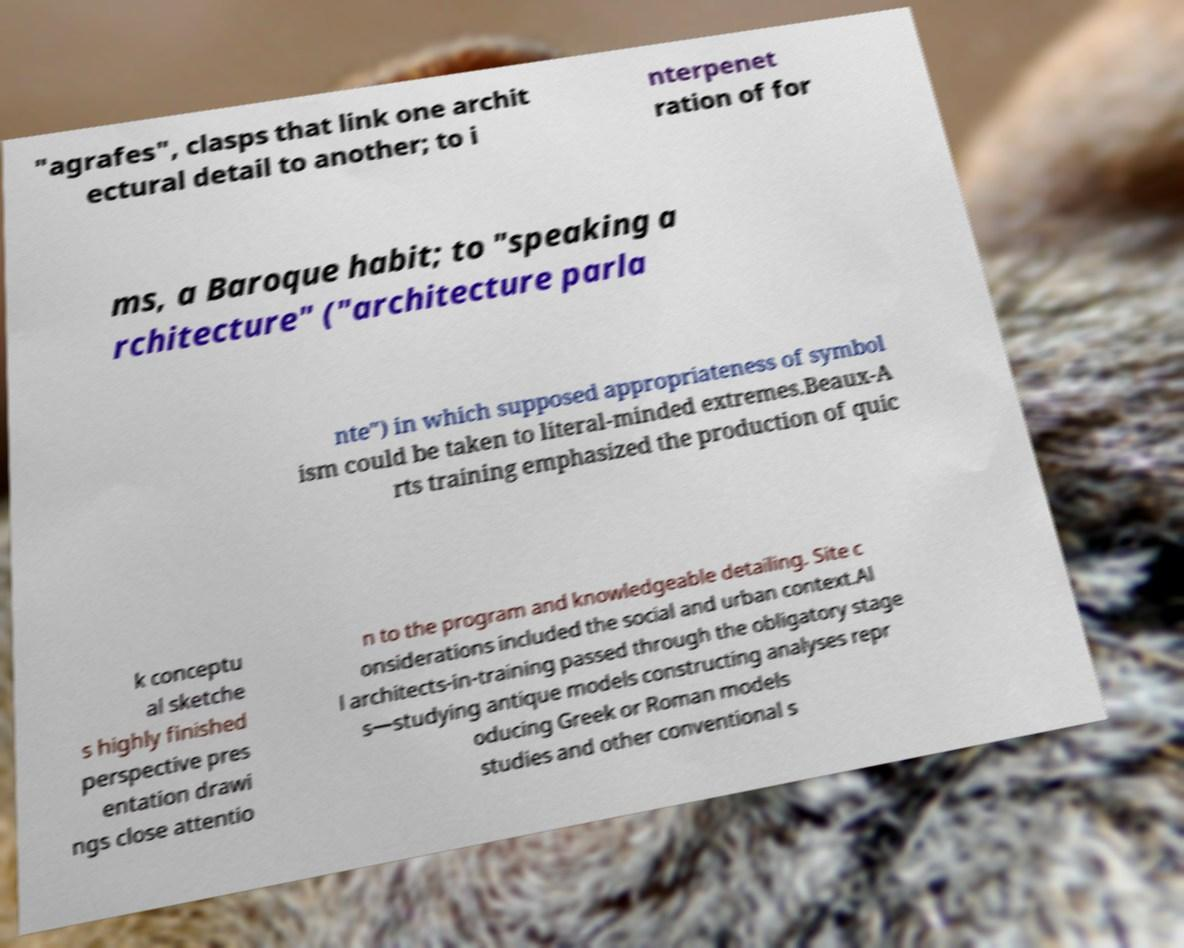For documentation purposes, I need the text within this image transcribed. Could you provide that? "agrafes", clasps that link one archit ectural detail to another; to i nterpenet ration of for ms, a Baroque habit; to "speaking a rchitecture" ("architecture parla nte") in which supposed appropriateness of symbol ism could be taken to literal-minded extremes.Beaux-A rts training emphasized the production of quic k conceptu al sketche s highly finished perspective pres entation drawi ngs close attentio n to the program and knowledgeable detailing. Site c onsiderations included the social and urban context.Al l architects-in-training passed through the obligatory stage s—studying antique models constructing analyses repr oducing Greek or Roman models studies and other conventional s 